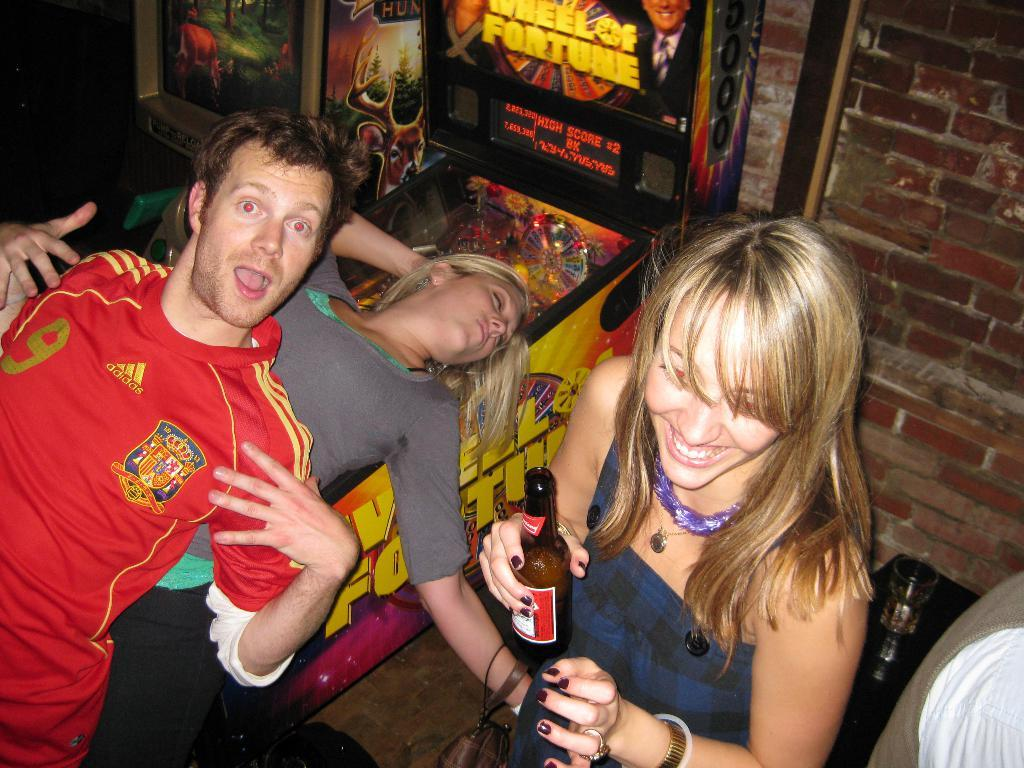Who can be seen in the image? There are people in the image. What is the woman holding in the image? The woman is holding a bottle. What type of surface is visible in the image? There is ground visible in the image. What else can be seen in the image besides people? There are objects in the image. What is visible in the background of the image? There is a wall in the background of the image. What type of cough can be heard in the image? There is no sound or indication of a cough in the image. 